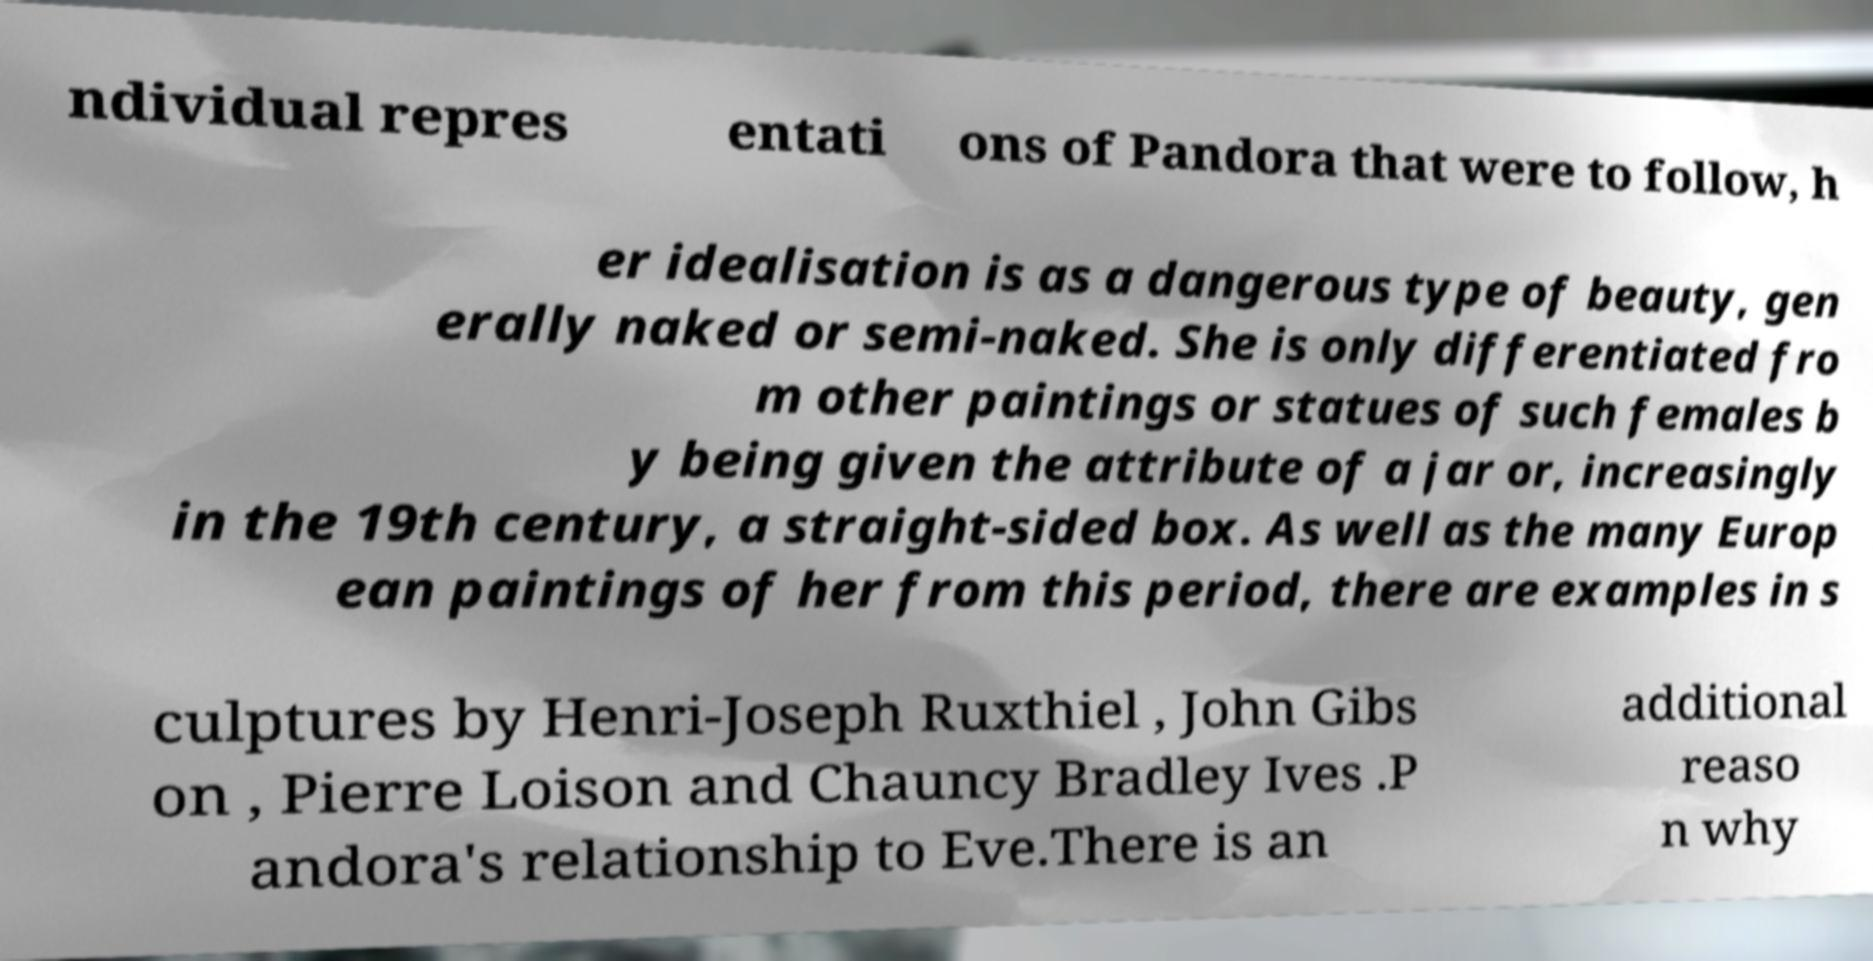I need the written content from this picture converted into text. Can you do that? ndividual repres entati ons of Pandora that were to follow, h er idealisation is as a dangerous type of beauty, gen erally naked or semi-naked. She is only differentiated fro m other paintings or statues of such females b y being given the attribute of a jar or, increasingly in the 19th century, a straight-sided box. As well as the many Europ ean paintings of her from this period, there are examples in s culptures by Henri-Joseph Ruxthiel , John Gibs on , Pierre Loison and Chauncy Bradley Ives .P andora's relationship to Eve.There is an additional reaso n why 